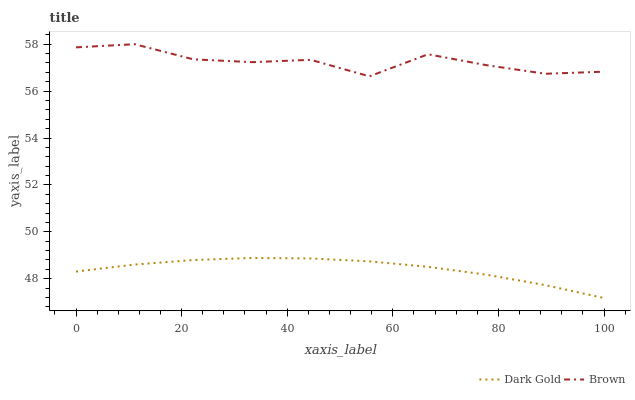Does Dark Gold have the minimum area under the curve?
Answer yes or no. Yes. Does Brown have the maximum area under the curve?
Answer yes or no. Yes. Does Dark Gold have the maximum area under the curve?
Answer yes or no. No. Is Dark Gold the smoothest?
Answer yes or no. Yes. Is Brown the roughest?
Answer yes or no. Yes. Is Dark Gold the roughest?
Answer yes or no. No. Does Dark Gold have the lowest value?
Answer yes or no. Yes. Does Brown have the highest value?
Answer yes or no. Yes. Does Dark Gold have the highest value?
Answer yes or no. No. Is Dark Gold less than Brown?
Answer yes or no. Yes. Is Brown greater than Dark Gold?
Answer yes or no. Yes. Does Dark Gold intersect Brown?
Answer yes or no. No. 